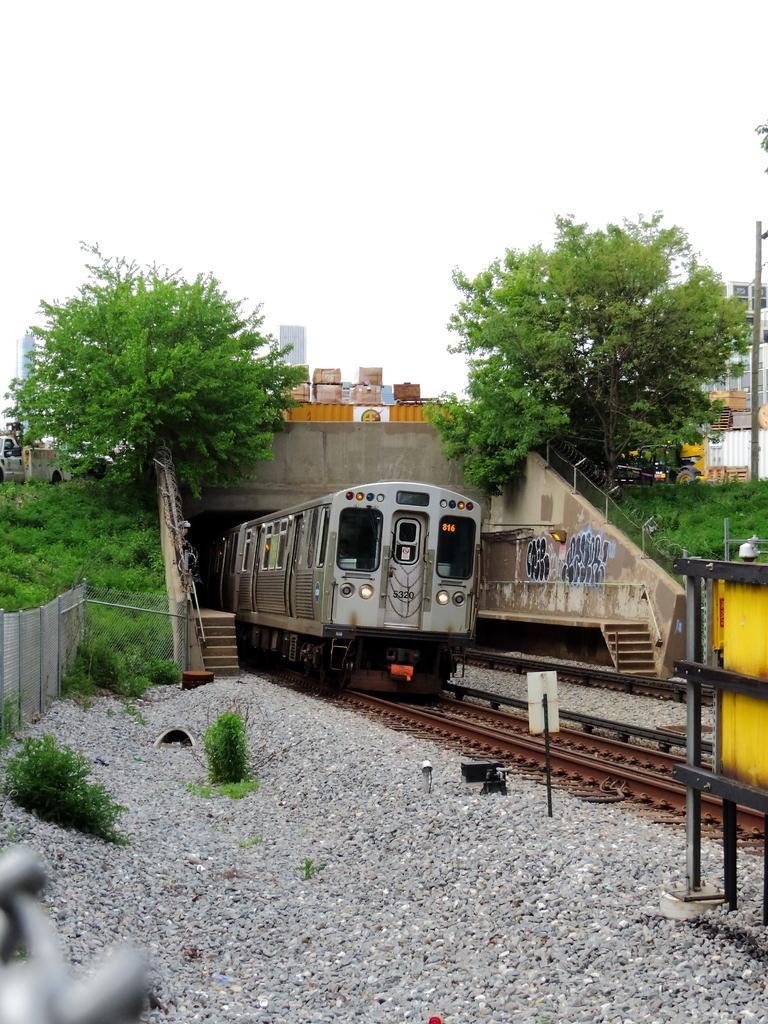Could you give a brief overview of what you see in this image? This picture shows train on the railway track and we see trees and buildings and we see a bridge and some vehicles moving on it and we see grass and few plants on the ground and a cloudy sky and we see graffiti on the wall. 